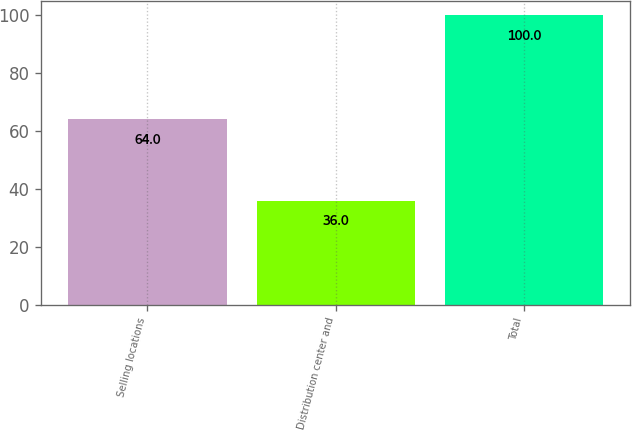<chart> <loc_0><loc_0><loc_500><loc_500><bar_chart><fcel>Selling locations<fcel>Distribution center and<fcel>Total<nl><fcel>64<fcel>36<fcel>100<nl></chart> 